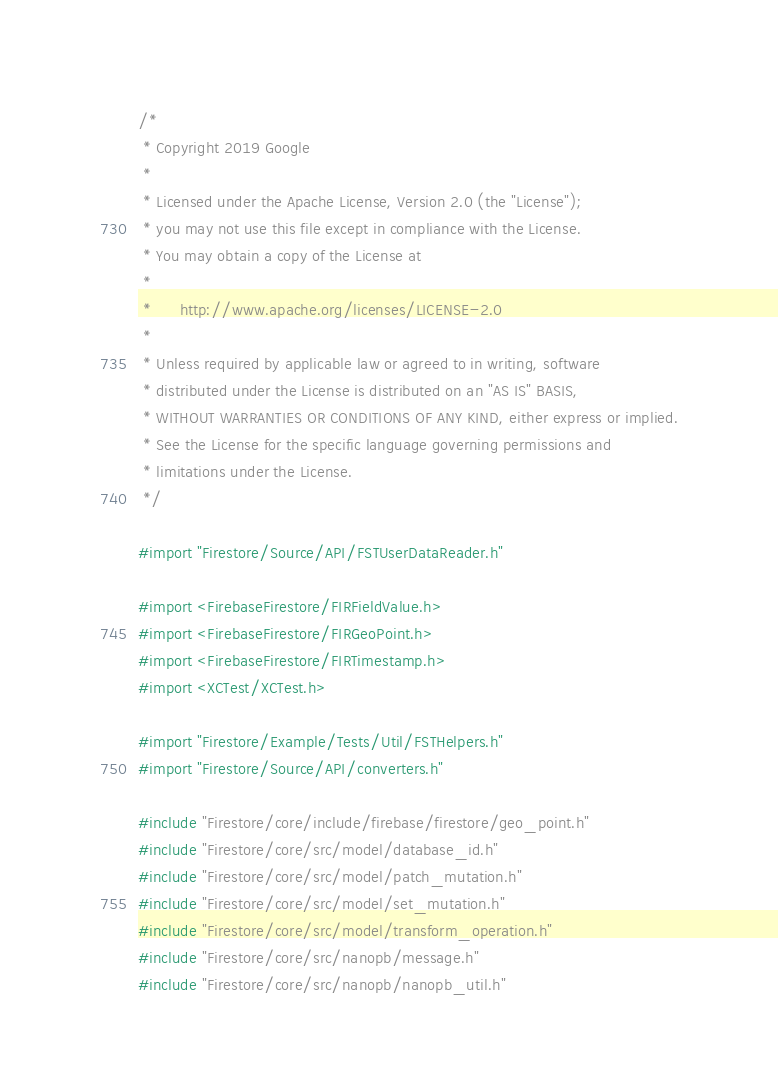Convert code to text. <code><loc_0><loc_0><loc_500><loc_500><_ObjectiveC_>/*
 * Copyright 2019 Google
 *
 * Licensed under the Apache License, Version 2.0 (the "License");
 * you may not use this file except in compliance with the License.
 * You may obtain a copy of the License at
 *
 *      http://www.apache.org/licenses/LICENSE-2.0
 *
 * Unless required by applicable law or agreed to in writing, software
 * distributed under the License is distributed on an "AS IS" BASIS,
 * WITHOUT WARRANTIES OR CONDITIONS OF ANY KIND, either express or implied.
 * See the License for the specific language governing permissions and
 * limitations under the License.
 */

#import "Firestore/Source/API/FSTUserDataReader.h"

#import <FirebaseFirestore/FIRFieldValue.h>
#import <FirebaseFirestore/FIRGeoPoint.h>
#import <FirebaseFirestore/FIRTimestamp.h>
#import <XCTest/XCTest.h>

#import "Firestore/Example/Tests/Util/FSTHelpers.h"
#import "Firestore/Source/API/converters.h"

#include "Firestore/core/include/firebase/firestore/geo_point.h"
#include "Firestore/core/src/model/database_id.h"
#include "Firestore/core/src/model/patch_mutation.h"
#include "Firestore/core/src/model/set_mutation.h"
#include "Firestore/core/src/model/transform_operation.h"
#include "Firestore/core/src/nanopb/message.h"
#include "Firestore/core/src/nanopb/nanopb_util.h"</code> 